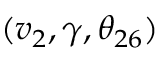<formula> <loc_0><loc_0><loc_500><loc_500>( v _ { 2 } , \gamma , \theta _ { 2 6 } )</formula> 